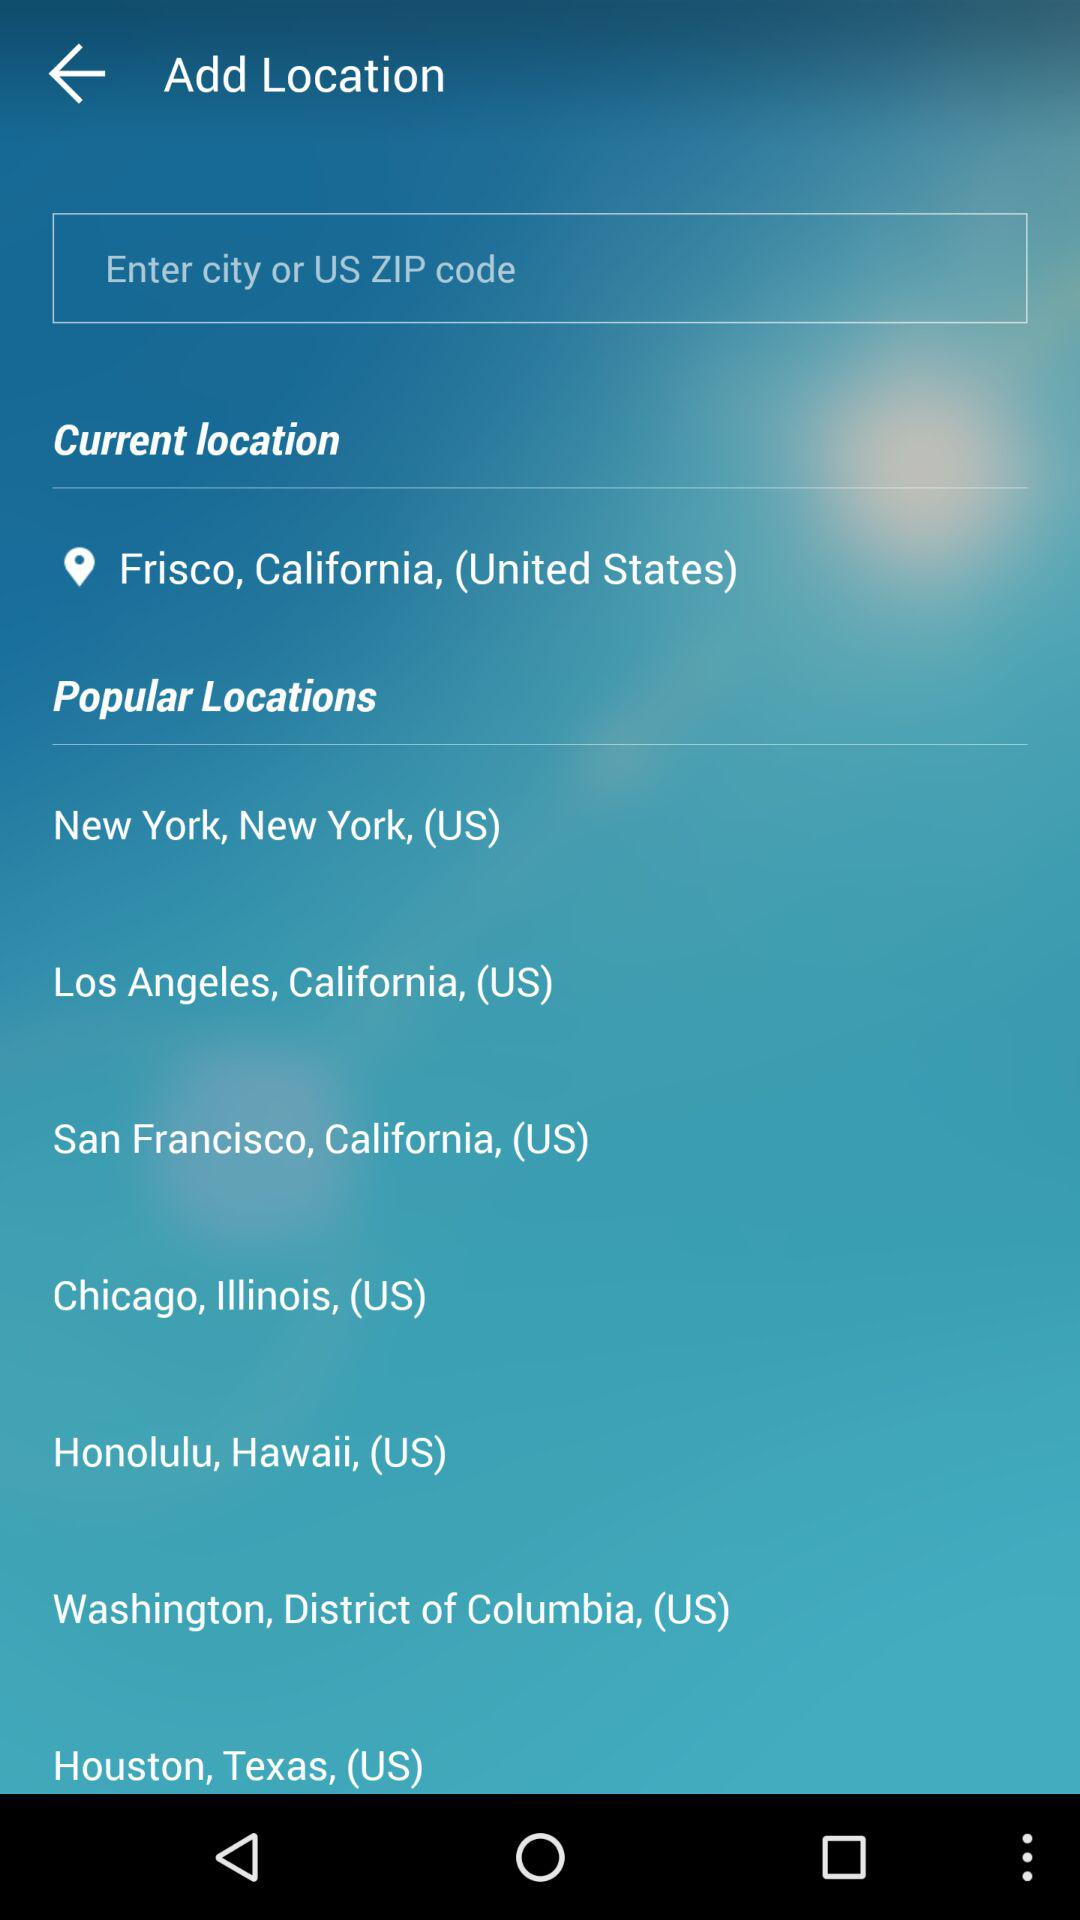What is the popular location in Washington state?
When the provided information is insufficient, respond with <no answer>. <no answer> 